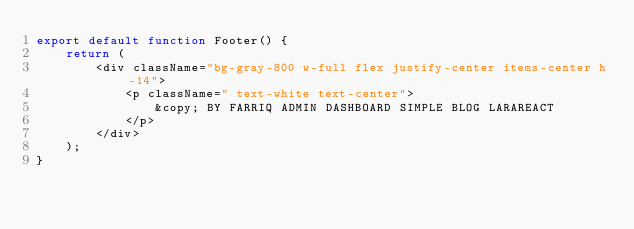<code> <loc_0><loc_0><loc_500><loc_500><_JavaScript_>export default function Footer() {
    return (
        <div className="bg-gray-800 w-full flex justify-center items-center h-14">
            <p className=" text-white text-center">
                &copy; BY FARRIQ ADMIN DASHBOARD SIMPLE BLOG LARAREACT
            </p>
        </div>
    );
}
</code> 